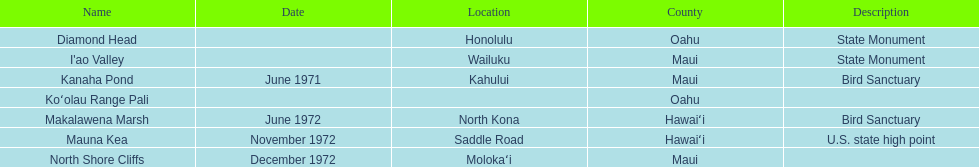How many landmarks can be found in maui in total? 3. Write the full table. {'header': ['Name', 'Date', 'Location', 'County', 'Description'], 'rows': [['Diamond Head', '', 'Honolulu', 'Oahu', 'State Monument'], ["I'ao Valley", '', 'Wailuku', 'Maui', 'State Monument'], ['Kanaha Pond', 'June 1971', 'Kahului', 'Maui', 'Bird Sanctuary'], ['Koʻolau Range Pali', '', '', 'Oahu', ''], ['Makalawena Marsh', 'June 1972', 'North Kona', 'Hawaiʻi', 'Bird Sanctuary'], ['Mauna Kea', 'November 1972', 'Saddle Road', 'Hawaiʻi', 'U.S. state high point'], ['North Shore Cliffs', 'December 1972', 'Molokaʻi', 'Maui', '']]} 